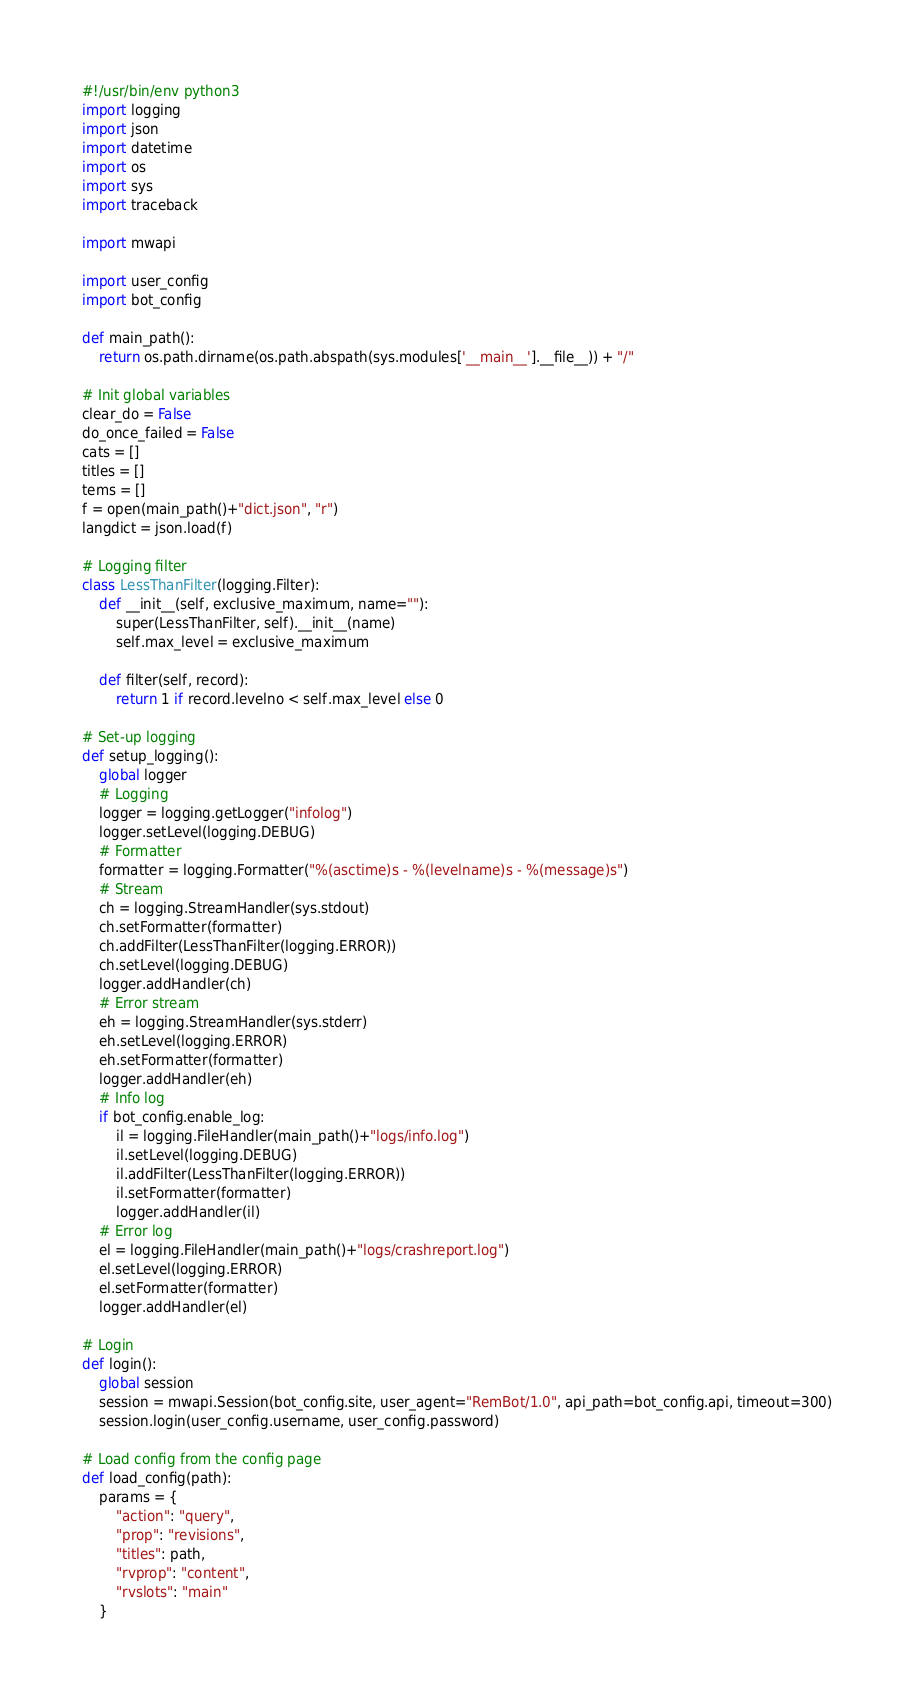Convert code to text. <code><loc_0><loc_0><loc_500><loc_500><_Python_>#!/usr/bin/env python3
import logging
import json
import datetime
import os
import sys
import traceback

import mwapi

import user_config
import bot_config

def main_path():
    return os.path.dirname(os.path.abspath(sys.modules['__main__'].__file__)) + "/"

# Init global variables
clear_do = False
do_once_failed = False
cats = []
titles = []
tems = []
f = open(main_path()+"dict.json", "r")
langdict = json.load(f)

# Logging filter
class LessThanFilter(logging.Filter):
    def __init__(self, exclusive_maximum, name=""):
        super(LessThanFilter, self).__init__(name)
        self.max_level = exclusive_maximum

    def filter(self, record):
        return 1 if record.levelno < self.max_level else 0

# Set-up logging
def setup_logging():
    global logger
    # Logging
    logger = logging.getLogger("infolog")
    logger.setLevel(logging.DEBUG)
    # Formatter
    formatter = logging.Formatter("%(asctime)s - %(levelname)s - %(message)s")
    # Stream
    ch = logging.StreamHandler(sys.stdout)
    ch.setFormatter(formatter)
    ch.addFilter(LessThanFilter(logging.ERROR))
    ch.setLevel(logging.DEBUG)
    logger.addHandler(ch)
    # Error stream
    eh = logging.StreamHandler(sys.stderr)
    eh.setLevel(logging.ERROR)
    eh.setFormatter(formatter)
    logger.addHandler(eh)
    # Info log
    if bot_config.enable_log:
        il = logging.FileHandler(main_path()+"logs/info.log")
        il.setLevel(logging.DEBUG)
        il.addFilter(LessThanFilter(logging.ERROR))
        il.setFormatter(formatter)
        logger.addHandler(il)
    # Error log
    el = logging.FileHandler(main_path()+"logs/crashreport.log")
    el.setLevel(logging.ERROR)
    el.setFormatter(formatter)
    logger.addHandler(el)

# Login
def login():
    global session
    session = mwapi.Session(bot_config.site, user_agent="RemBot/1.0", api_path=bot_config.api, timeout=300)
    session.login(user_config.username, user_config.password)

# Load config from the config page
def load_config(path):
    params = {
        "action": "query",
        "prop": "revisions",
        "titles": path,
        "rvprop": "content",
        "rvslots": "main"
    }</code> 